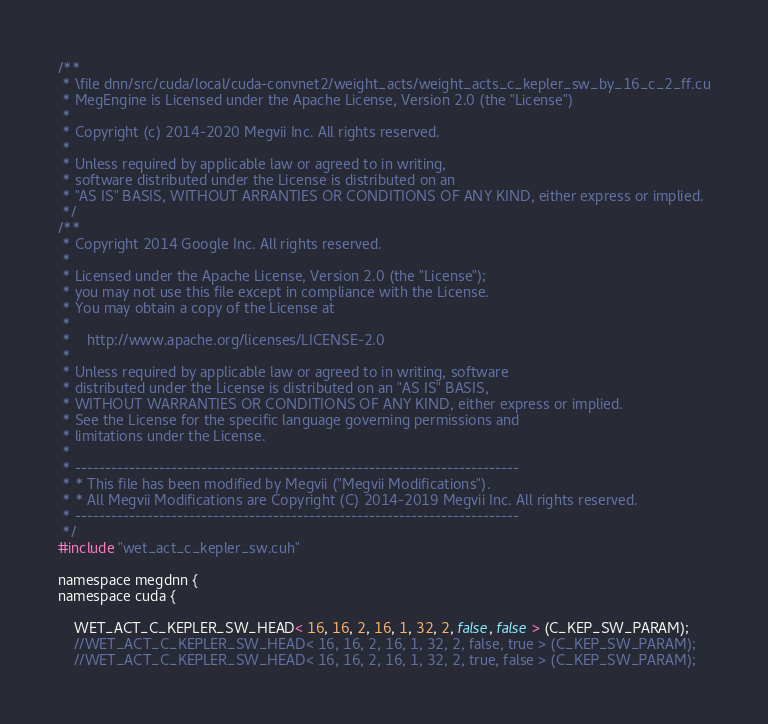Convert code to text. <code><loc_0><loc_0><loc_500><loc_500><_Cuda_>/**
 * \file dnn/src/cuda/local/cuda-convnet2/weight_acts/weight_acts_c_kepler_sw_by_16_c_2_ff.cu
 * MegEngine is Licensed under the Apache License, Version 2.0 (the "License")
 *
 * Copyright (c) 2014-2020 Megvii Inc. All rights reserved.
 *
 * Unless required by applicable law or agreed to in writing,
 * software distributed under the License is distributed on an
 * "AS IS" BASIS, WITHOUT ARRANTIES OR CONDITIONS OF ANY KIND, either express or implied.
 */
/**
 * Copyright 2014 Google Inc. All rights reserved.
 *
 * Licensed under the Apache License, Version 2.0 (the "License");
 * you may not use this file except in compliance with the License.
 * You may obtain a copy of the License at
 *
 *    http://www.apache.org/licenses/LICENSE-2.0
 *
 * Unless required by applicable law or agreed to in writing, software
 * distributed under the License is distributed on an "AS IS" BASIS,
 * WITHOUT WARRANTIES OR CONDITIONS OF ANY KIND, either express or implied.
 * See the License for the specific language governing permissions and
 * limitations under the License.
 *
 * --------------------------------------------------------------------------
 * * This file has been modified by Megvii ("Megvii Modifications").
 * * All Megvii Modifications are Copyright (C) 2014-2019 Megvii Inc. All rights reserved.
 * --------------------------------------------------------------------------
 */
#include "wet_act_c_kepler_sw.cuh"

namespace megdnn {
namespace cuda {

    WET_ACT_C_KEPLER_SW_HEAD< 16, 16, 2, 16, 1, 32, 2, false, false > (C_KEP_SW_PARAM);
    //WET_ACT_C_KEPLER_SW_HEAD< 16, 16, 2, 16, 1, 32, 2, false, true > (C_KEP_SW_PARAM);
    //WET_ACT_C_KEPLER_SW_HEAD< 16, 16, 2, 16, 1, 32, 2, true, false > (C_KEP_SW_PARAM);</code> 